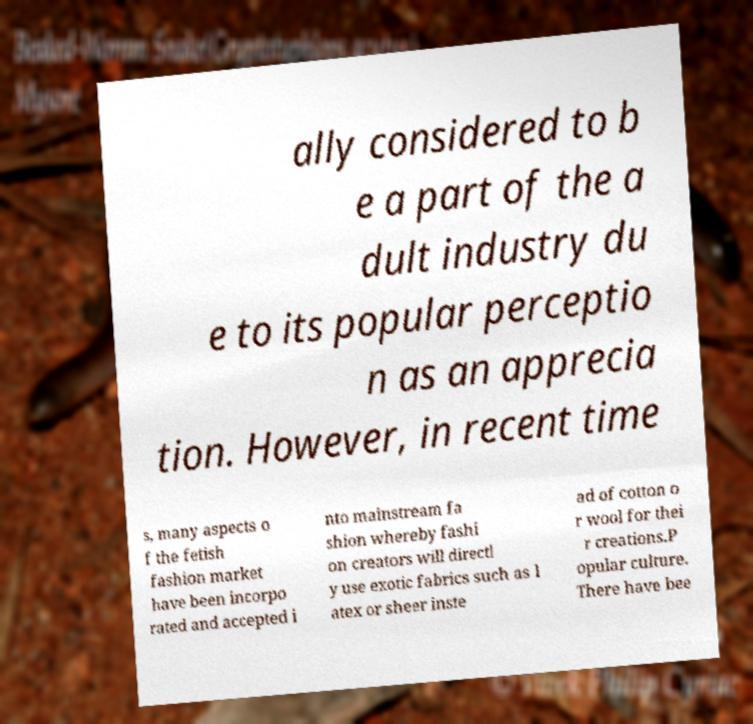For documentation purposes, I need the text within this image transcribed. Could you provide that? ally considered to b e a part of the a dult industry du e to its popular perceptio n as an apprecia tion. However, in recent time s, many aspects o f the fetish fashion market have been incorpo rated and accepted i nto mainstream fa shion whereby fashi on creators will directl y use exotic fabrics such as l atex or sheer inste ad of cotton o r wool for thei r creations.P opular culture. There have bee 